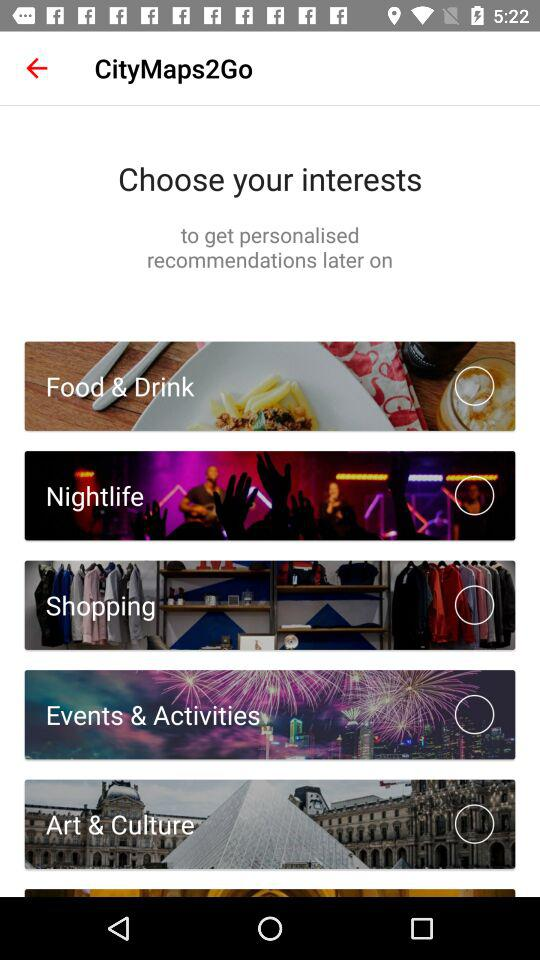Is "Shopping" selected or not? "Shopping" is not selected. 